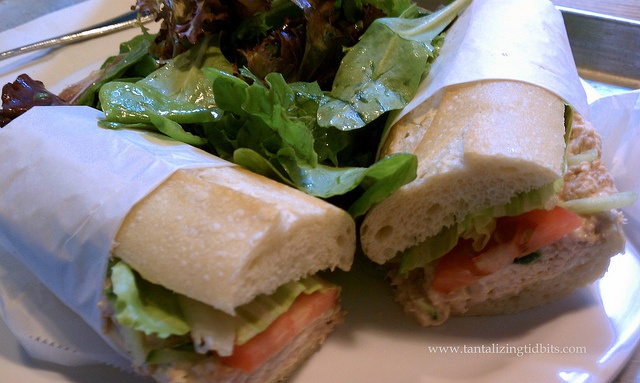Describe the objects in this image and their specific colors. I can see sandwich in gray and darkgray tones, sandwich in gray, lavender, maroon, and black tones, and fork in gray, white, and darkgray tones in this image. 